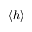<formula> <loc_0><loc_0><loc_500><loc_500>\langle h \rangle</formula> 